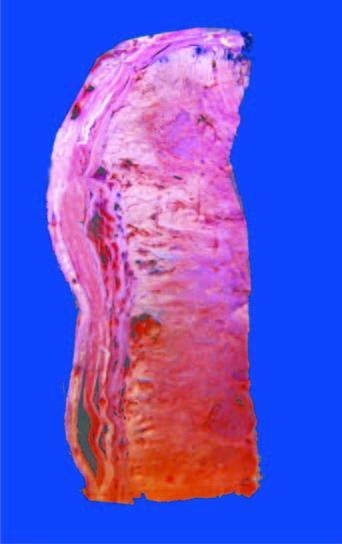s cut surface of the tumour grey-white, cystic, soft and friable?
Answer the question using a single word or phrase. Yes 